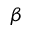Convert formula to latex. <formula><loc_0><loc_0><loc_500><loc_500>\beta</formula> 